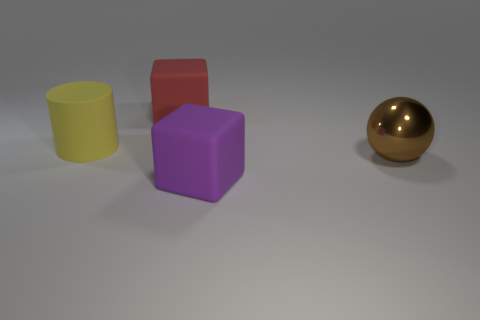Add 1 purple matte cubes. How many objects exist? 5 Subtract all balls. How many objects are left? 3 Add 2 green cubes. How many green cubes exist? 2 Subtract 0 cyan cubes. How many objects are left? 4 Subtract all large blocks. Subtract all metal things. How many objects are left? 1 Add 3 purple objects. How many purple objects are left? 4 